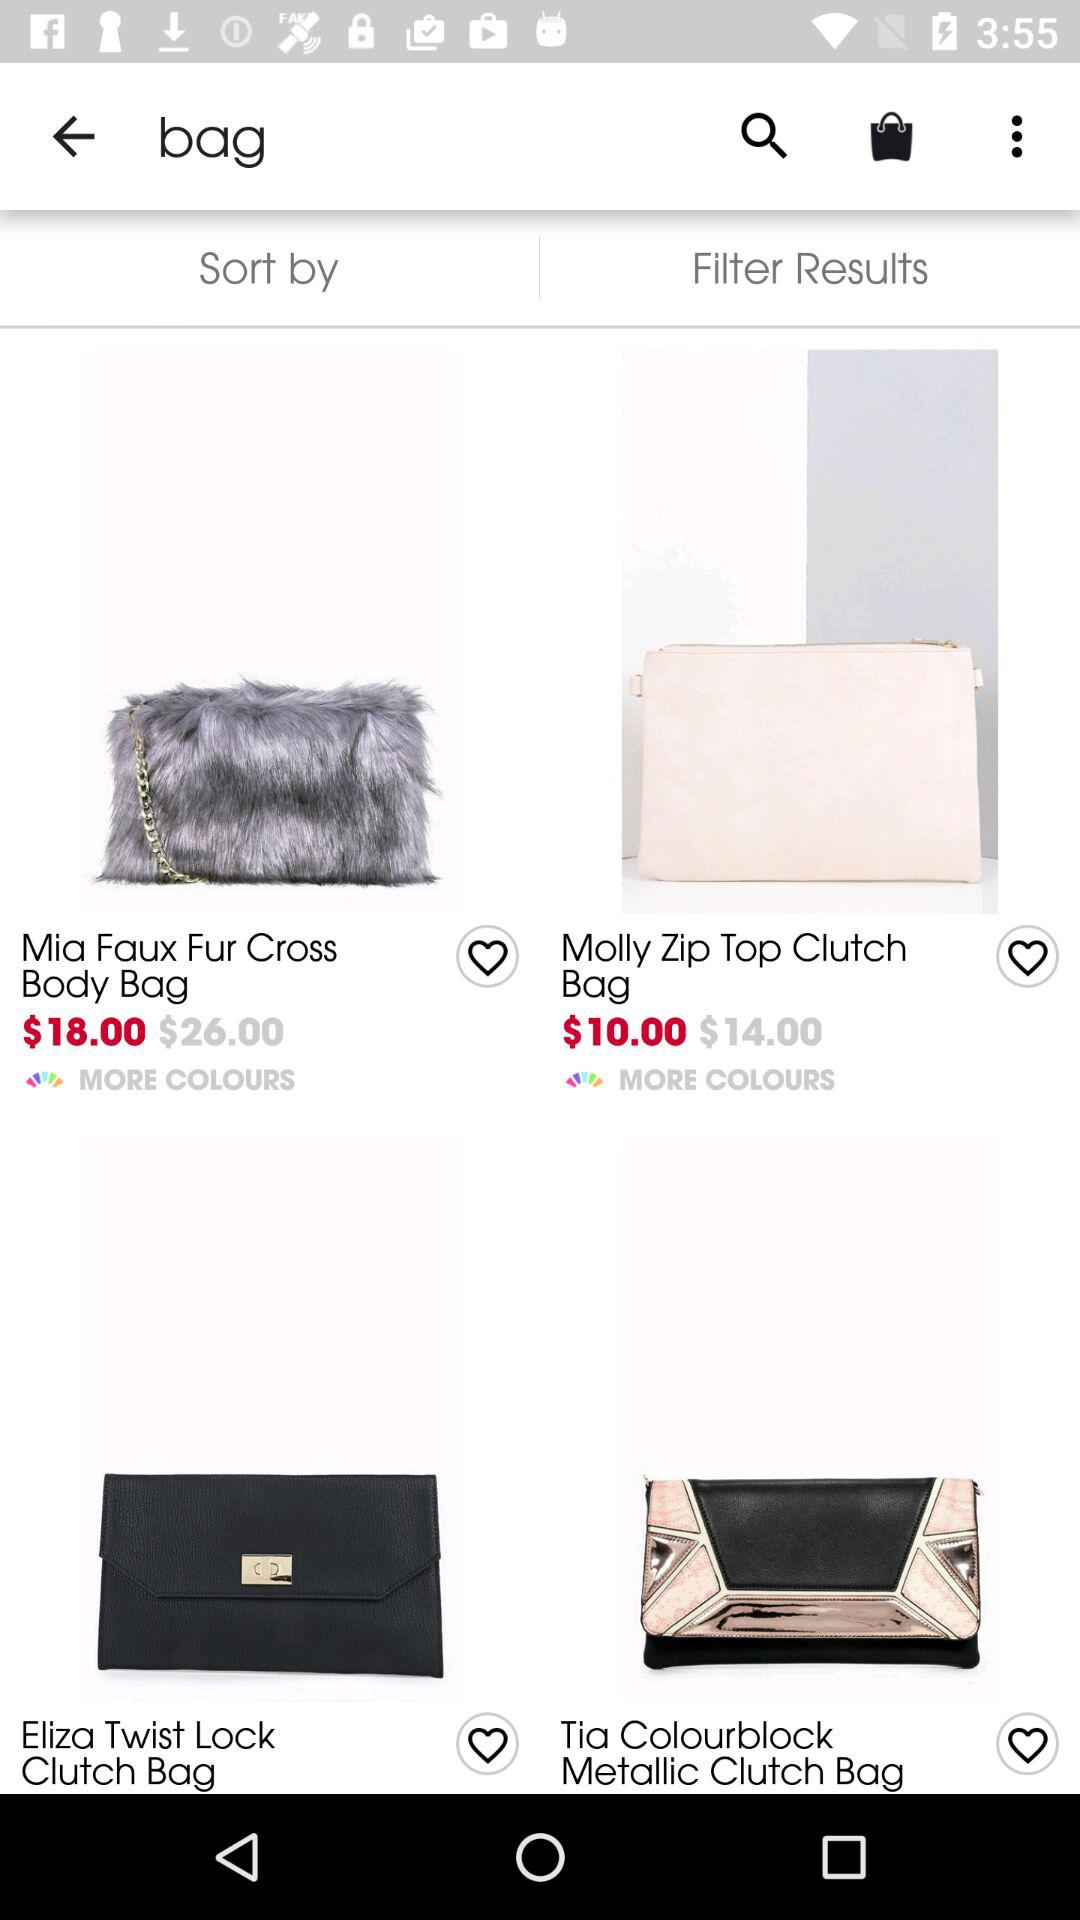How many bags are priced between $10 and $20?
Answer the question using a single word or phrase. 2 